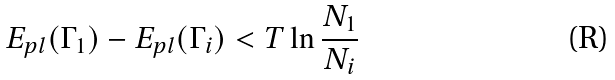Convert formula to latex. <formula><loc_0><loc_0><loc_500><loc_500>E _ { p l } ( \Gamma _ { 1 } ) - E _ { p l } ( \Gamma _ { i } ) < T \ln \frac { N _ { 1 } } { N _ { i } }</formula> 